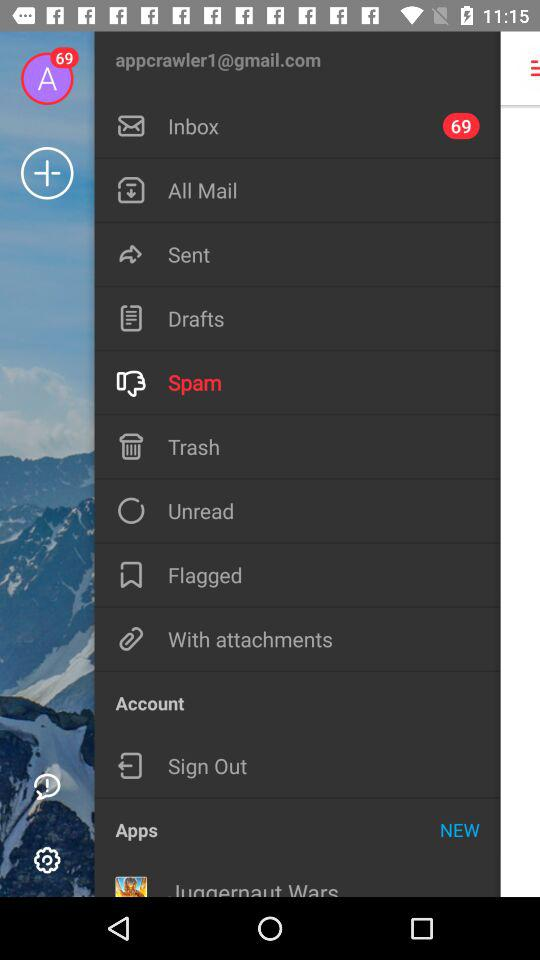How many unread emails are there in the inbox? There are 69 unread emails. 